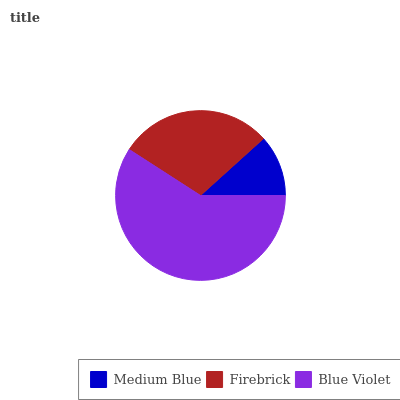Is Medium Blue the minimum?
Answer yes or no. Yes. Is Blue Violet the maximum?
Answer yes or no. Yes. Is Firebrick the minimum?
Answer yes or no. No. Is Firebrick the maximum?
Answer yes or no. No. Is Firebrick greater than Medium Blue?
Answer yes or no. Yes. Is Medium Blue less than Firebrick?
Answer yes or no. Yes. Is Medium Blue greater than Firebrick?
Answer yes or no. No. Is Firebrick less than Medium Blue?
Answer yes or no. No. Is Firebrick the high median?
Answer yes or no. Yes. Is Firebrick the low median?
Answer yes or no. Yes. Is Medium Blue the high median?
Answer yes or no. No. Is Medium Blue the low median?
Answer yes or no. No. 